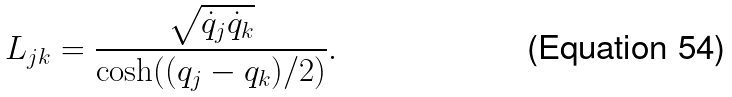Convert formula to latex. <formula><loc_0><loc_0><loc_500><loc_500>L _ { j k } = \frac { \sqrt { \dot { q } _ { j } \dot { q } _ { k } } } { \cosh ( ( q _ { j } - q _ { k } ) / 2 ) } .</formula> 